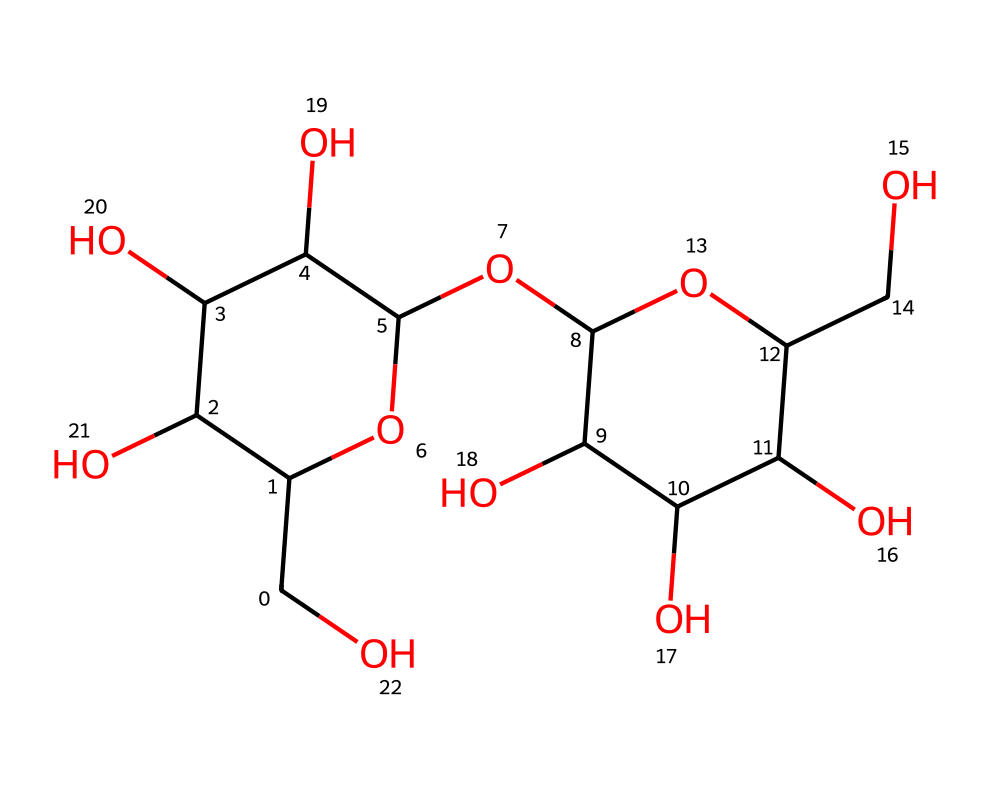What is the molecular formula of lactose? By analyzing the SMILES representation, we identify the elements present and their quantities. The structure contains 12 carbons (C), 22 hydrogens (H), and 11 oxygens (O), leading to the molecular formula C12H22O11.
Answer: C12H22O11 How many rings are present in the structure of lactose? The SMILES notation indicates the presence of ring structures, as denoted by the numbers (C1 and C2). There are two numbers indicating the start and end of each ring, showing that there are two cyclic structures in lactose.
Answer: 2 What is the type of carbohydrate represented by this structure? Lactose consists of two monosaccharides: glucose and galactose. It is specifically classified as a disaccharide, as disaccharides are composed of two monosaccharide units linked by a glycosidic bond.
Answer: disaccharide How many hydroxyl (-OH) groups are present in lactose? Count the -OH groups in the structure based on the hydroxyl groups attached to carbon atoms. Each indicated ‘O’ within the formula corresponds to a hydroxyl group. Lactose has 6 -OH groups, making it a hydrophilic molecule.
Answer: 6 What is the functional group that characterizes lactose? Analyzing the structure, lactose features a glycosidic bond between the two monosaccharides, connecting them and characterizing it as an ether link with hydroxyl functionalities contributing to its properties.
Answer: glycosidic bond What type of isomerism can lactose exhibit? The presence of multiple stereocenters in the structure allows lactose to exhibit stereoisomerism, specifically alpha and beta forms. This occurs due to the orientation of the hydroxyl group on the first carbon of glucose.
Answer: stereoisomerism 